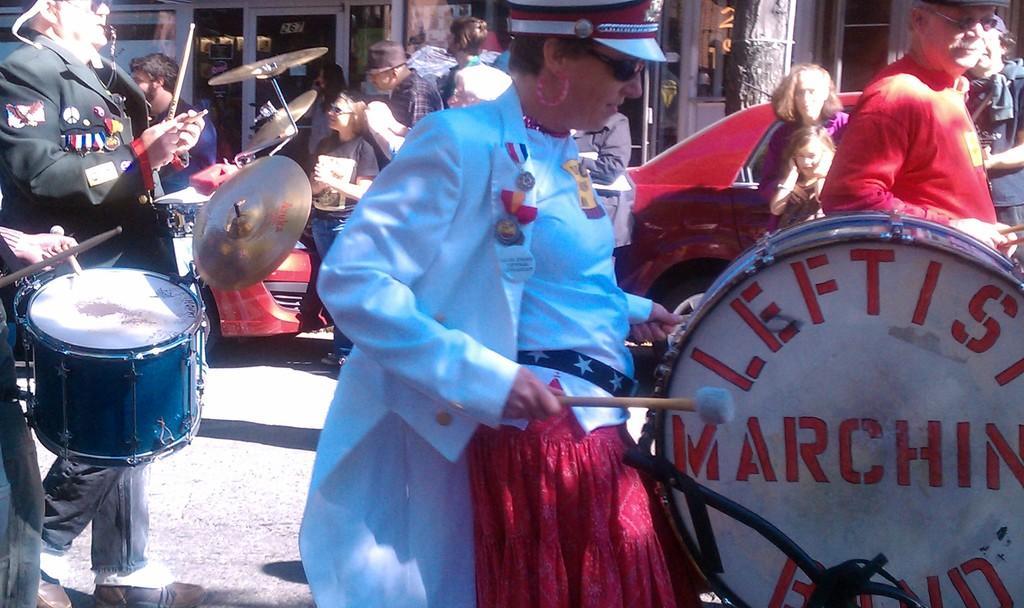Describe this image in one or two sentences. In this picture we can see some people are playing musical instruments on the road, side we can see some vehicles, buildings. 